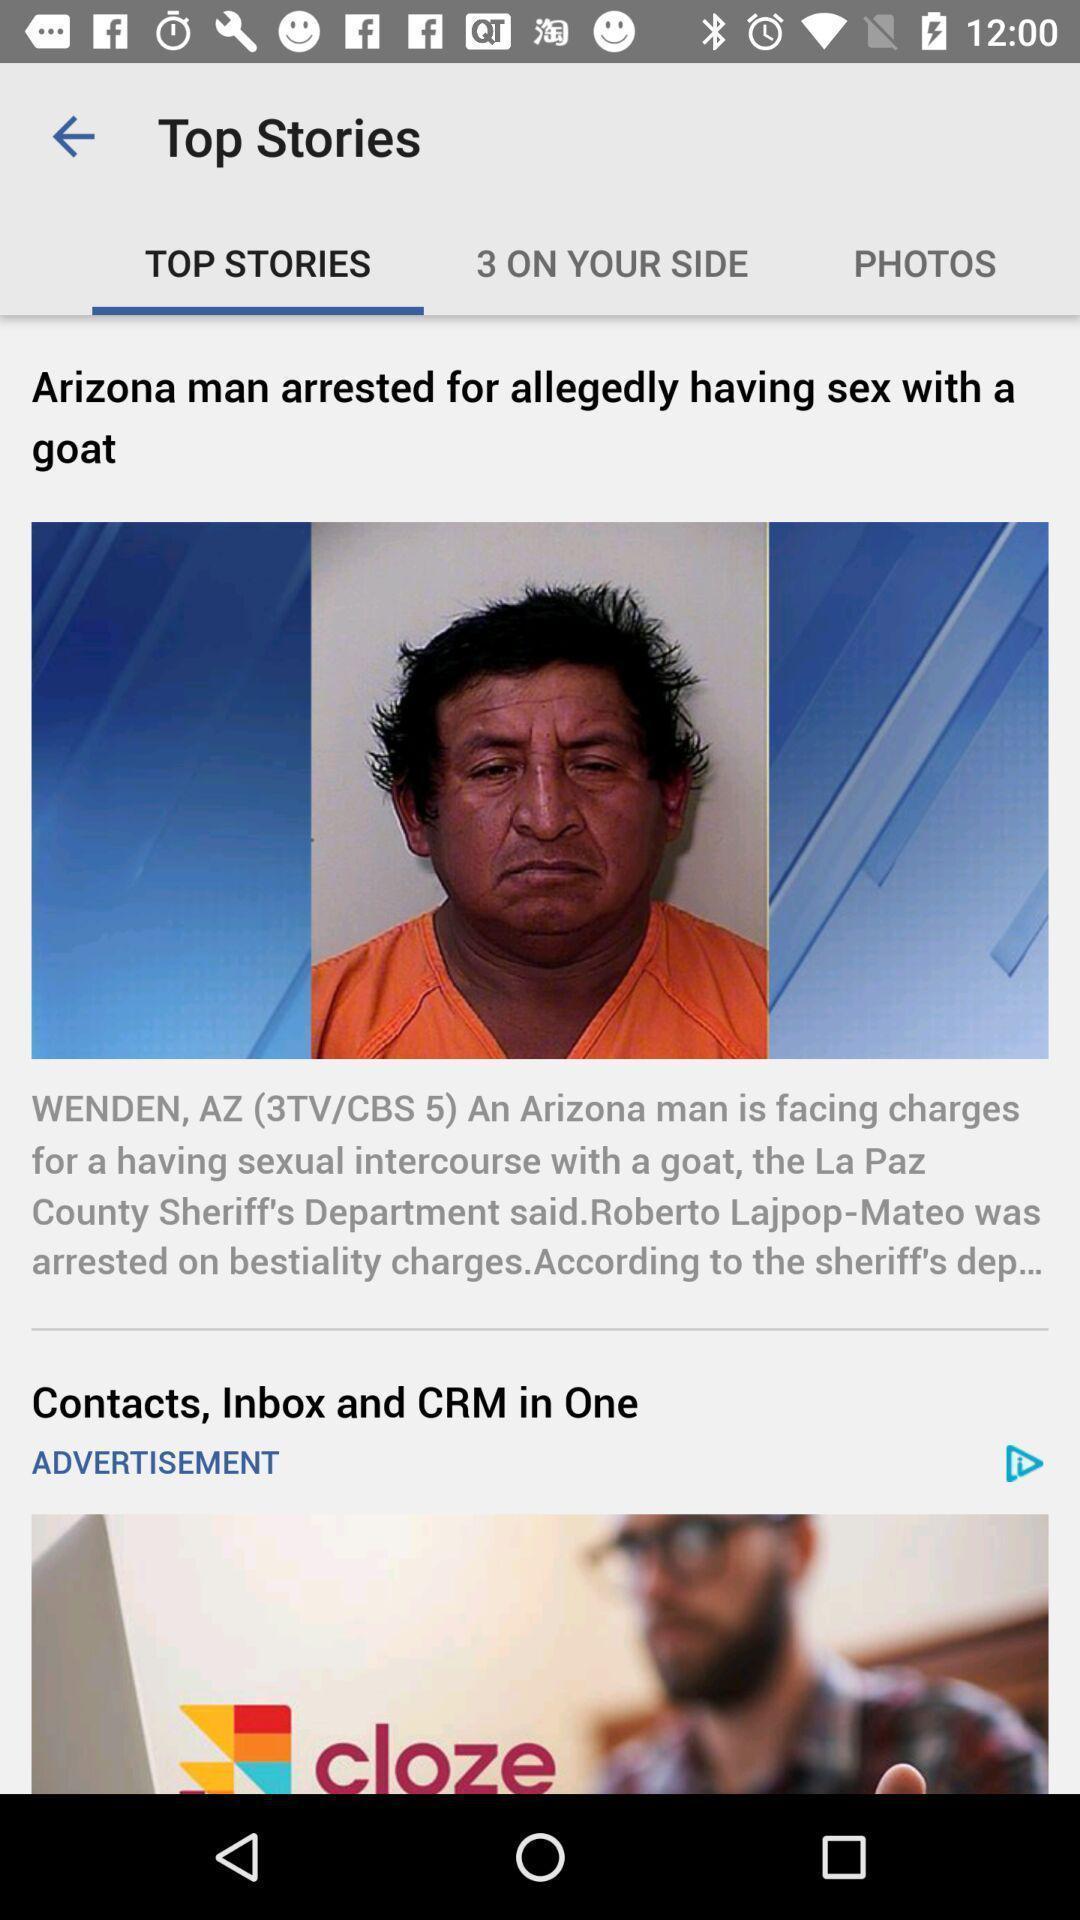Describe the key features of this screenshot. Screen showing top stories. 